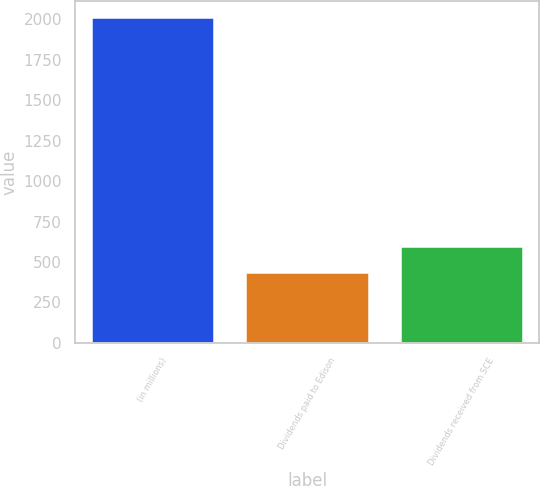<chart> <loc_0><loc_0><loc_500><loc_500><bar_chart><fcel>(in millions)<fcel>Dividends paid to Edison<fcel>Dividends received from SCE<nl><fcel>2013<fcel>440<fcel>597.3<nl></chart> 